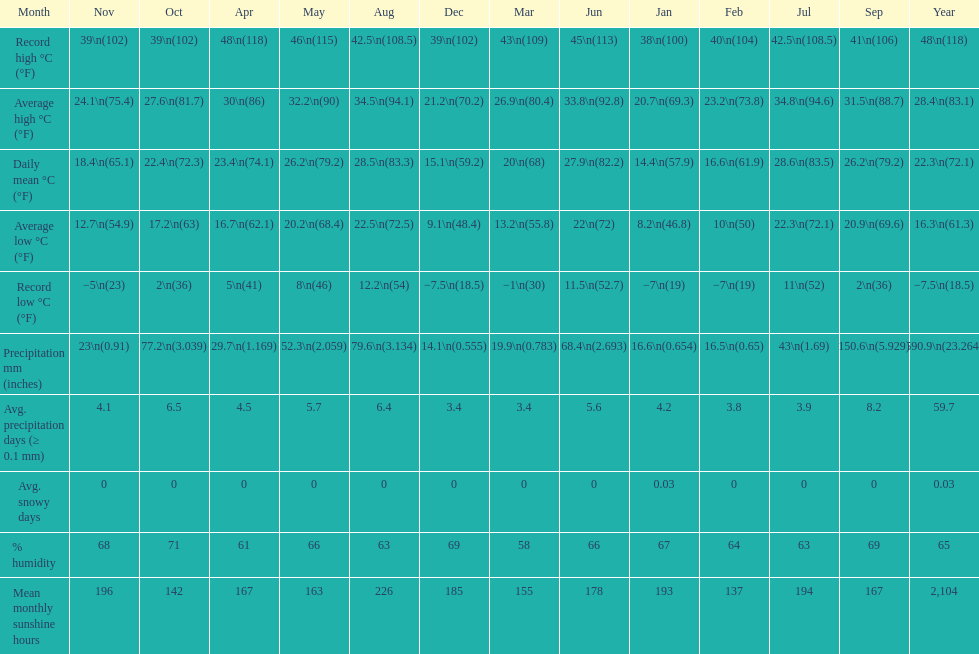Which month had the most sunny days? August. 